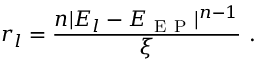<formula> <loc_0><loc_0><loc_500><loc_500>r _ { l } = \frac { n | E _ { l } - E _ { E P } | ^ { n - 1 } } { \xi } \ .</formula> 